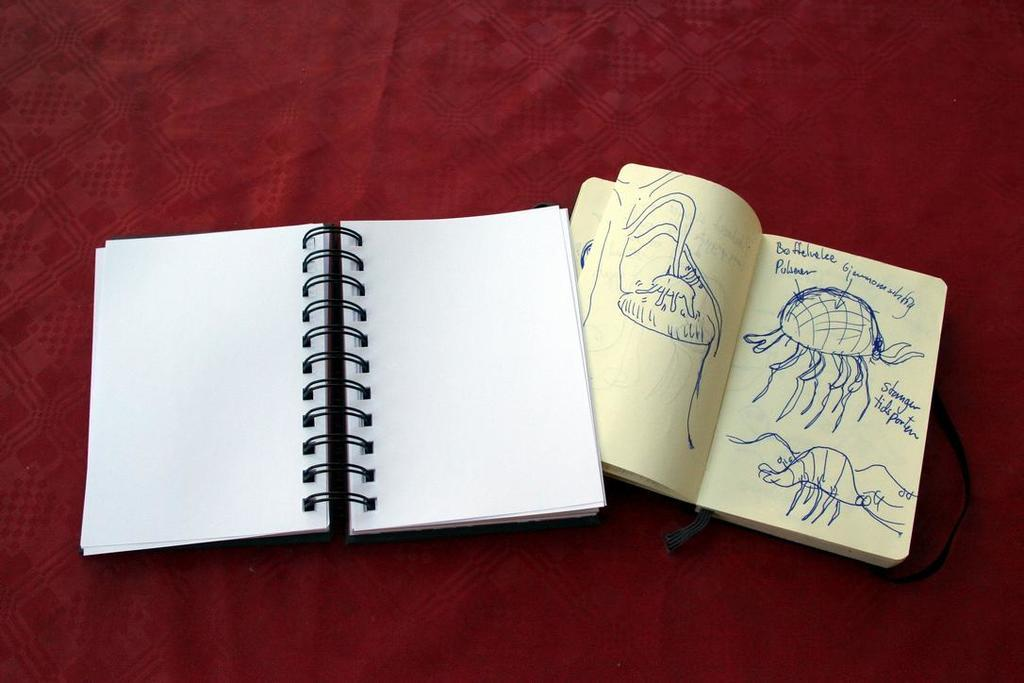How many notebooks are visible in the image? There are two notebooks in the image. What is the color of the cloth on which the notebooks are placed? The cloth is maroon-colored. What type of tin can be seen next to the notebooks in the image? There is no tin present in the image; only the two notebooks and the maroon-colored cloth are visible. 